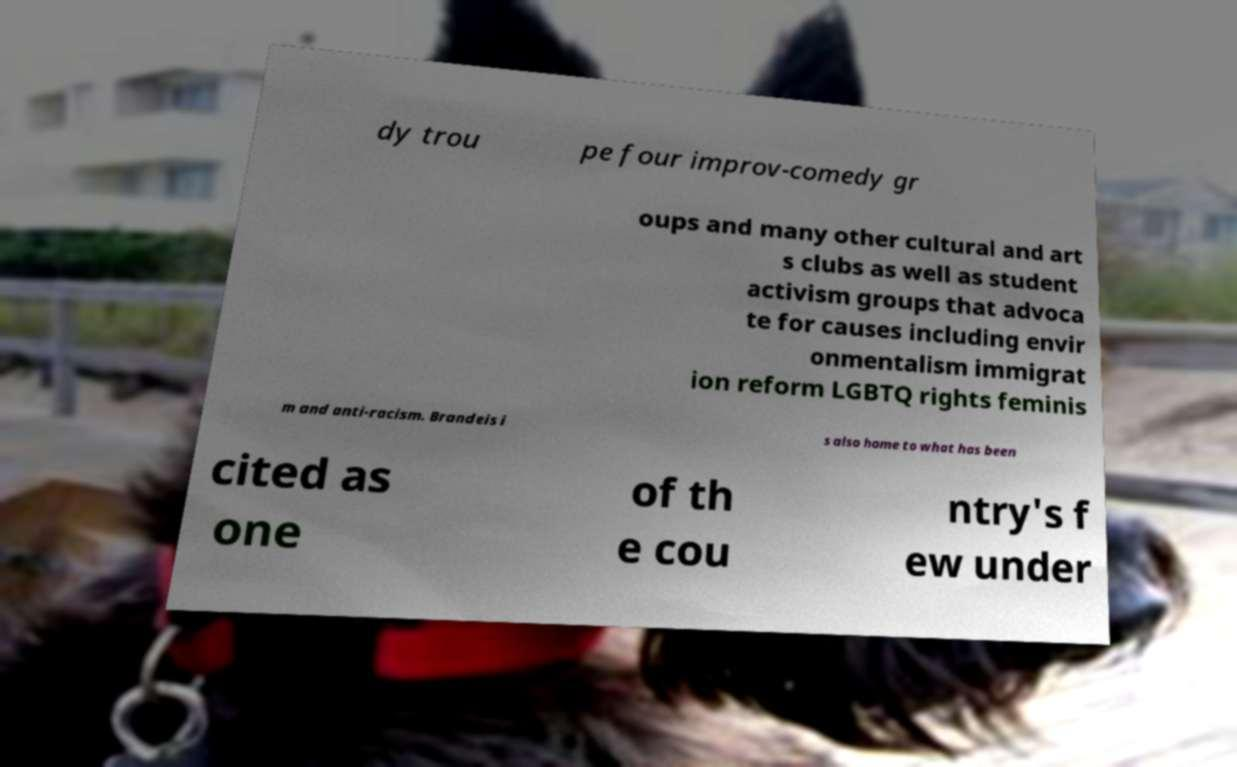For documentation purposes, I need the text within this image transcribed. Could you provide that? dy trou pe four improv-comedy gr oups and many other cultural and art s clubs as well as student activism groups that advoca te for causes including envir onmentalism immigrat ion reform LGBTQ rights feminis m and anti-racism. Brandeis i s also home to what has been cited as one of th e cou ntry's f ew under 